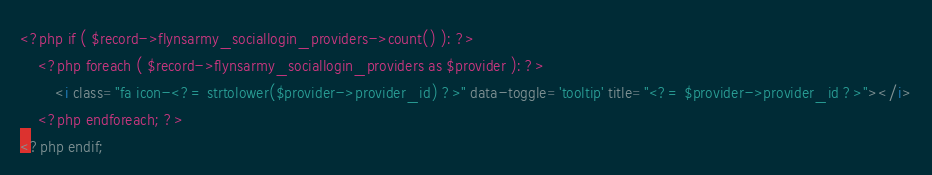Convert code to text. <code><loc_0><loc_0><loc_500><loc_500><_HTML_><?php if ( $record->flynsarmy_sociallogin_providers->count() ): ?>
    <?php foreach ( $record->flynsarmy_sociallogin_providers as $provider ): ?>
        <i class="fa icon-<?= strtolower($provider->provider_id) ?>" data-toggle='tooltip' title="<?= $provider->provider_id ?>"></i>
    <?php endforeach; ?>
<?php endif;</code> 